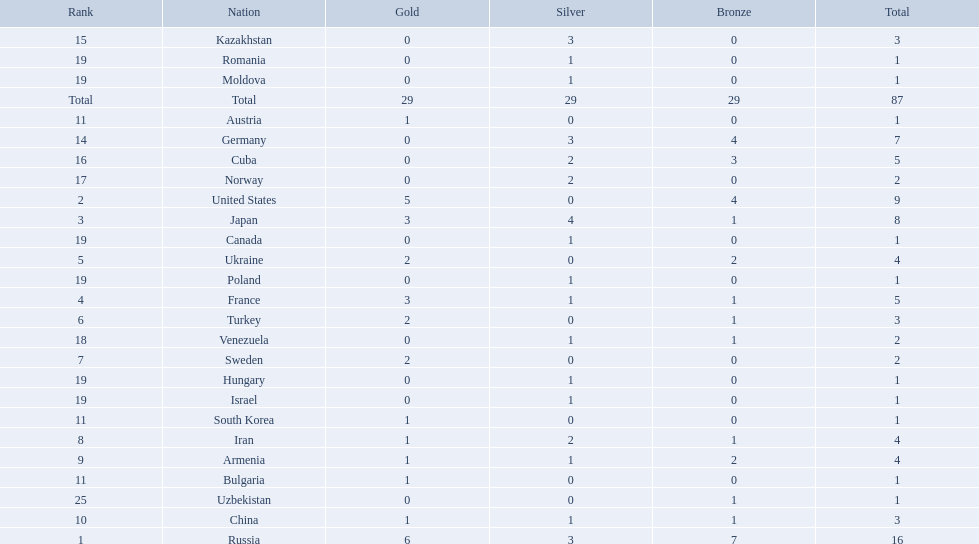Which nations only won less then 5 medals? Ukraine, Turkey, Sweden, Iran, Armenia, China, Austria, Bulgaria, South Korea, Germany, Kazakhstan, Norway, Venezuela, Canada, Hungary, Israel, Moldova, Poland, Romania, Uzbekistan. Which of these were not asian nations? Ukraine, Turkey, Sweden, Iran, Armenia, Austria, Bulgaria, Germany, Kazakhstan, Norway, Venezuela, Canada, Hungary, Israel, Moldova, Poland, Romania, Uzbekistan. Which of those did not win any silver medals? Ukraine, Turkey, Sweden, Austria, Bulgaria, Uzbekistan. Which ones of these had only one medal total? Austria, Bulgaria, Uzbekistan. Which of those would be listed first alphabetically? Austria. 